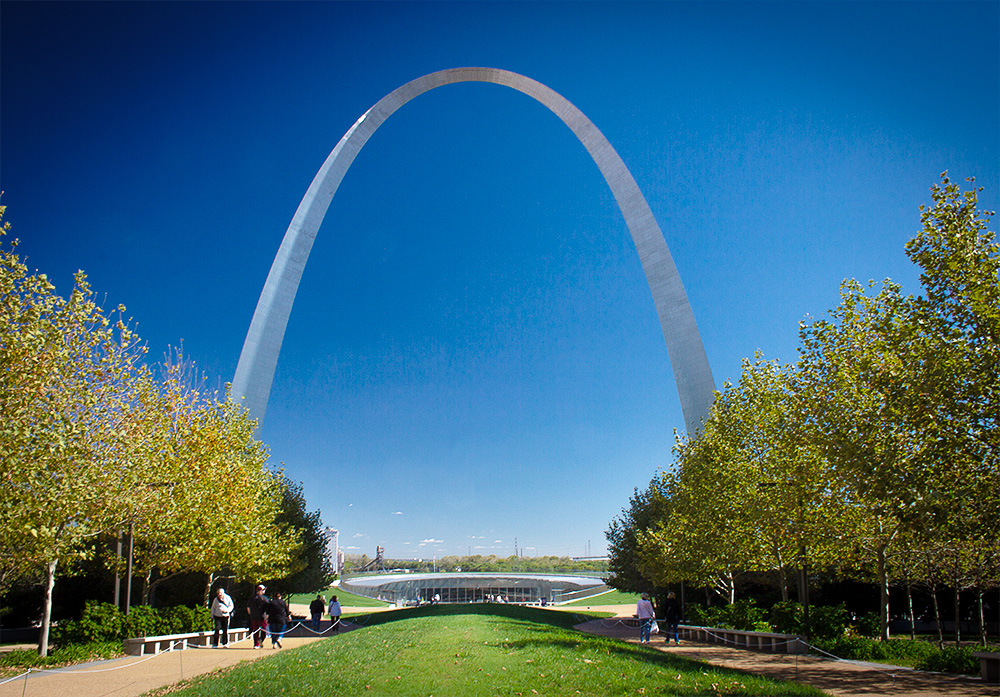Can you give a detailed description of the landscape surrounding the arch as shown in the image? The landscape around the Gateway Arch is a harmonious blend of urban and natural elements. The image shows well-manicured green spaces, with rows of deciduous trees that suggest a vibrant, life-filled park setting. These trees, beginning to show autumnal colors, line pathways that invite visitors to stroll and enjoy the serene environment. The presence of people walking and relaxing in the park adds a dynamic human element to the otherwise tranquil setting. The river visible in the background further enhances the natural appeal of the location. 